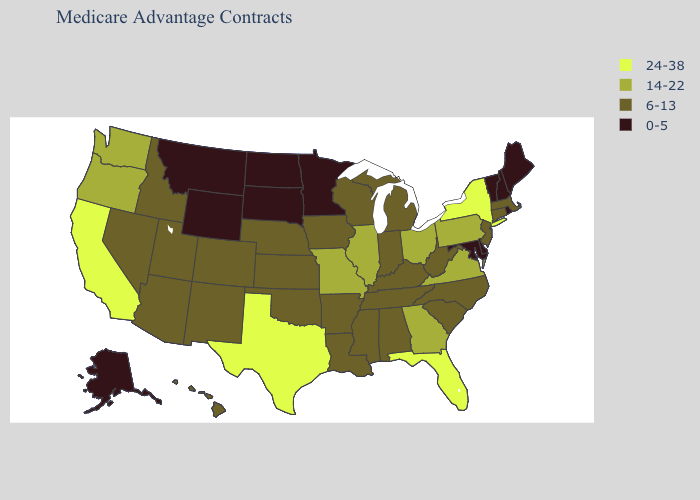What is the value of Michigan?
Quick response, please. 6-13. Name the states that have a value in the range 14-22?
Be succinct. Georgia, Illinois, Missouri, Ohio, Oregon, Pennsylvania, Virginia, Washington. Name the states that have a value in the range 6-13?
Short answer required. Alabama, Arkansas, Arizona, Colorado, Connecticut, Hawaii, Iowa, Idaho, Indiana, Kansas, Kentucky, Louisiana, Massachusetts, Michigan, Mississippi, North Carolina, Nebraska, New Jersey, New Mexico, Nevada, Oklahoma, South Carolina, Tennessee, Utah, Wisconsin, West Virginia. Does West Virginia have a higher value than Oklahoma?
Concise answer only. No. Does South Carolina have the lowest value in the South?
Give a very brief answer. No. Among the states that border Virginia , which have the highest value?
Answer briefly. Kentucky, North Carolina, Tennessee, West Virginia. What is the highest value in the USA?
Concise answer only. 24-38. What is the lowest value in states that border West Virginia?
Short answer required. 0-5. Does Texas have a higher value than Florida?
Answer briefly. No. What is the lowest value in states that border Pennsylvania?
Be succinct. 0-5. Does the first symbol in the legend represent the smallest category?
Concise answer only. No. What is the value of Pennsylvania?
Be succinct. 14-22. Name the states that have a value in the range 0-5?
Write a very short answer. Alaska, Delaware, Maryland, Maine, Minnesota, Montana, North Dakota, New Hampshire, Rhode Island, South Dakota, Vermont, Wyoming. What is the value of Maryland?
Give a very brief answer. 0-5. 